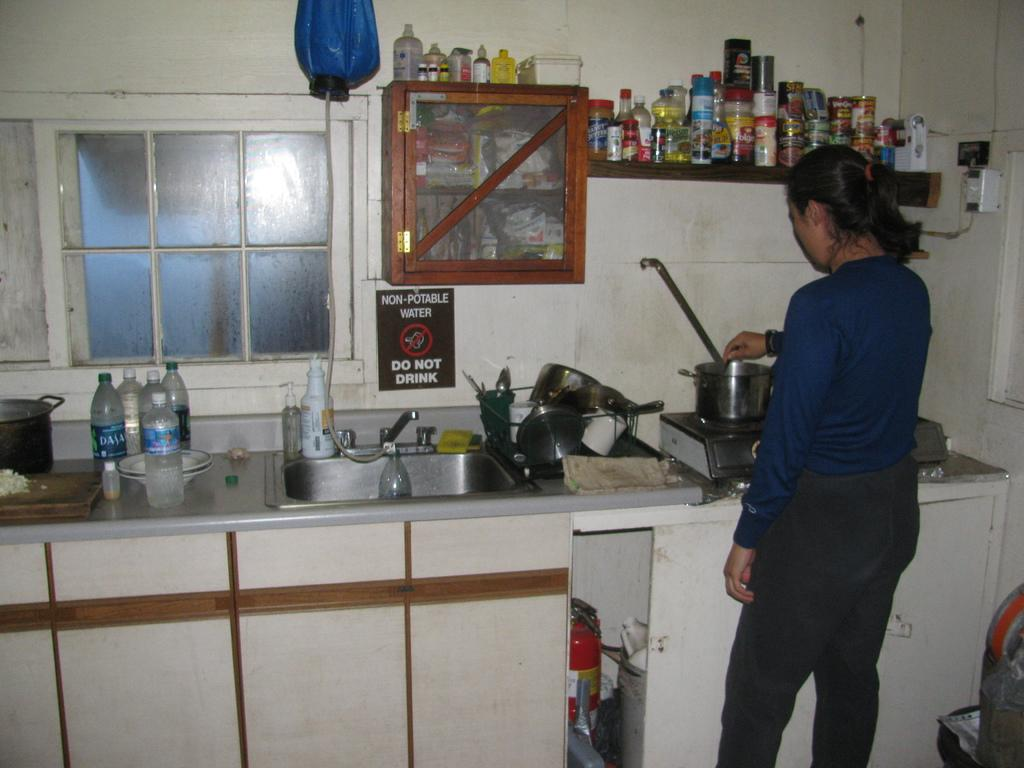<image>
Describe the image concisely. A sign on the wall says NON POTABLE WATER DO NO DRINK. 